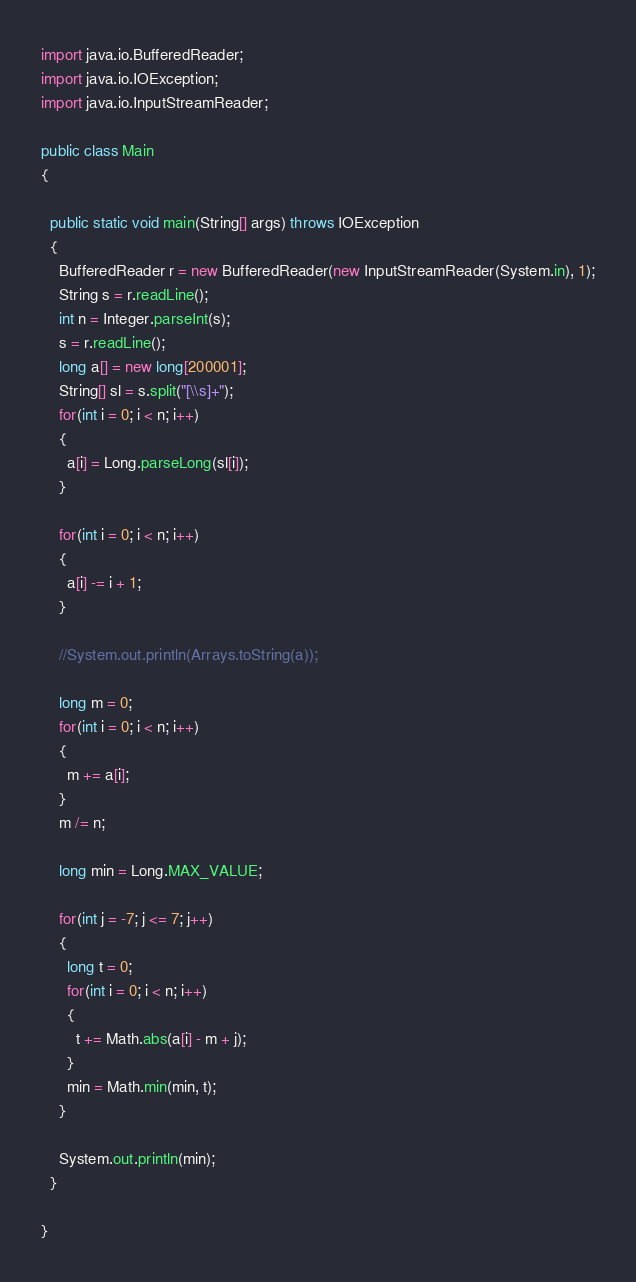<code> <loc_0><loc_0><loc_500><loc_500><_Java_>
import java.io.BufferedReader;
import java.io.IOException;
import java.io.InputStreamReader;

public class Main
{

  public static void main(String[] args) throws IOException
  {
    BufferedReader r = new BufferedReader(new InputStreamReader(System.in), 1);
    String s = r.readLine();
    int n = Integer.parseInt(s);
    s = r.readLine();
    long a[] = new long[200001];
    String[] sl = s.split("[\\s]+");
    for(int i = 0; i < n; i++)
    {
      a[i] = Long.parseLong(sl[i]);
    }

    for(int i = 0; i < n; i++)
    {
      a[i] -= i + 1;
    }

    //System.out.println(Arrays.toString(a));

    long m = 0;
    for(int i = 0; i < n; i++)
    {
      m += a[i];
    }
    m /= n;

    long min = Long.MAX_VALUE;

    for(int j = -7; j <= 7; j++)
    {
      long t = 0;
      for(int i = 0; i < n; i++)
      {
        t += Math.abs(a[i] - m + j);
      }
      min = Math.min(min, t);
    }

    System.out.println(min);
  }

}
</code> 